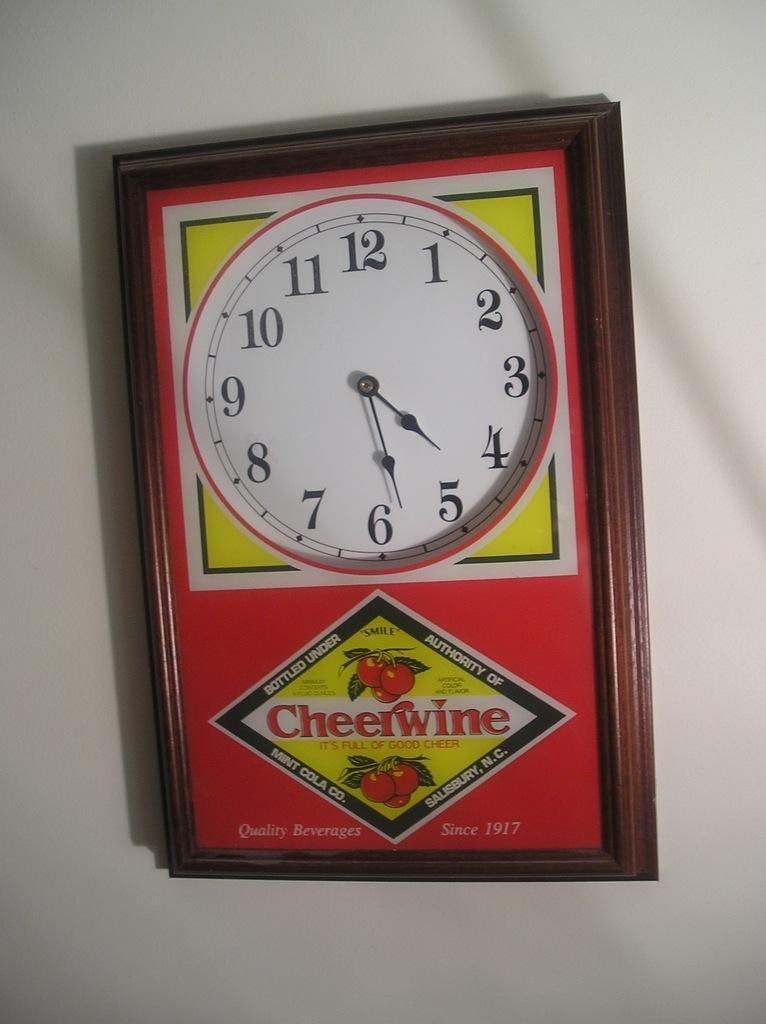<image>
Render a clear and concise summary of the photo. The cheerwine clock is a little crooked on the wall. 